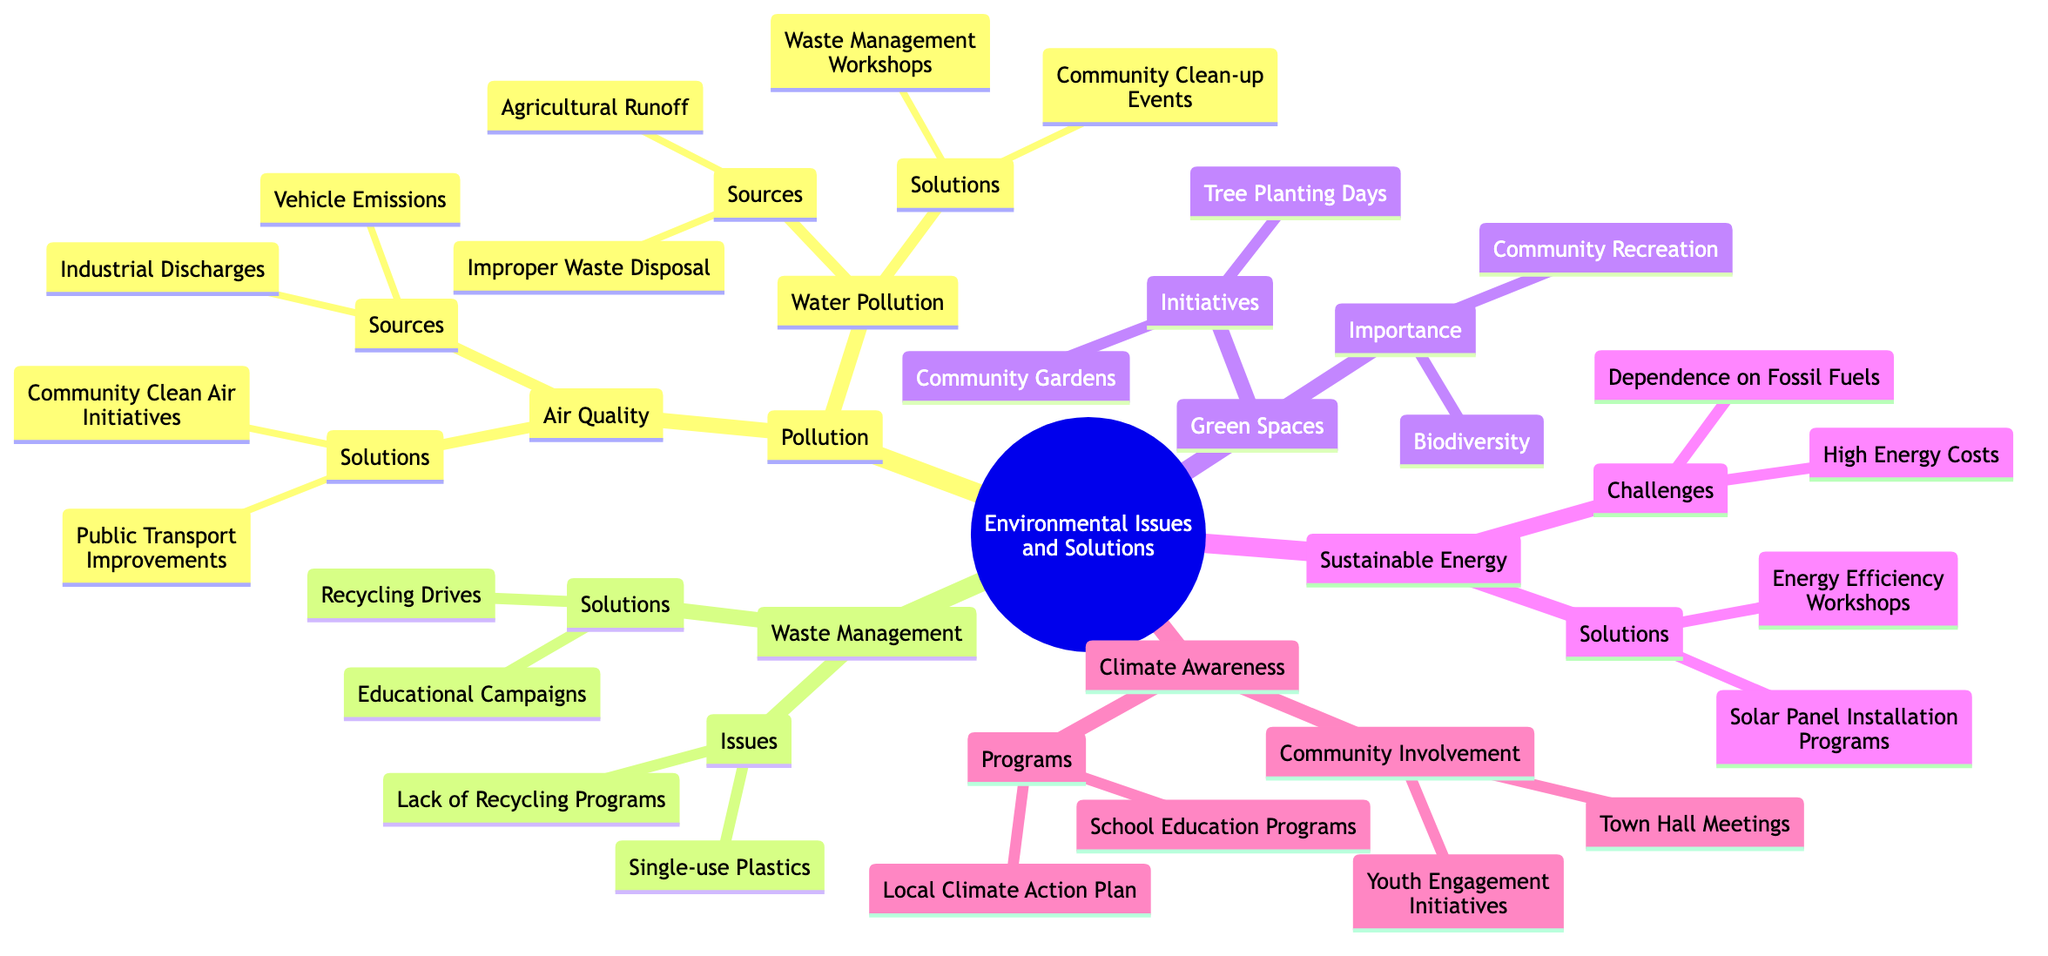What are the two sources of Air Quality pollution? The diagram lists "Vehicle Emissions" and "Industrial Discharges" under the Air Quality node, which are highlighted as sources contributing to pollution.
Answer: Vehicle Emissions, Industrial Discharges How many solutions are provided for Water Pollution? Under the Water Pollution node, there are two listed solutions: "Community Clean-up Events" and "Waste Management Workshops," which can be counted for a total.
Answer: 2 What are the two main issues in Waste Management? The Waste Management node identifies "Single-use Plastics" and "Lack of Recycling Programs" as two specific problems highlighted in the diagram.
Answer: Single-use Plastics, Lack of Recycling Programs What initiatives are mentioned for Green Spaces? The initiatives listed under Green Spaces include "Community Gardens" and "Tree Planting Days," which are aimed at enhancing green areas in the community.
Answer: Community Gardens, Tree Planting Days Which two challenges are highlighted in Sustainable Energy? The diagram indicates "Dependence on Fossil Fuels" and "High Energy Costs" as the primary challenges associated with Sustainable Energy, found under this specific node.
Answer: Dependence on Fossil Fuels, High Energy Costs How is community involvement illustrated within Climate Awareness? Community involvement is represented by "Town Hall Meetings" and "Youth Engagement Initiatives," indicating ways locals can participate in climate awareness efforts.
Answer: Town Hall Meetings, Youth Engagement Initiatives What are the two programs listed under Climate Awareness? The diagram specifies two programs: "Local Climate Action Plan" and "School Education Programs," focused on enhancing climate awareness in the community.
Answer: Local Climate Action Plan, School Education Programs Which node contains information about solutions related to Waste Management? The solutions for Waste Management are explicitly illustrated under the node named Waste Management, detailing specific actions to address the identified problems.
Answer: Waste Management How many types of pollution are mentioned in the diagram? There are two types of pollution described in the diagram under the Pollution node: Air Quality and Water Pollution, which can be counted for this total.
Answer: 2 